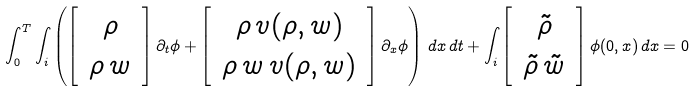<formula> <loc_0><loc_0><loc_500><loc_500>\int _ { 0 } ^ { T } \int _ { \real i } \left ( \left [ \, \begin{array} { c } \rho \\ \rho \, w \end{array} \, \right ] \partial _ { t } \phi + \left [ \, \begin{array} { c } \rho \, v ( \rho , w ) \\ \rho \, w \, v ( \rho , w ) \end{array} \, \right ] \partial _ { x } \phi \right ) \, d x \, d t + \int _ { \real i } \left [ \, \begin{array} { c } \tilde { \rho } \\ \tilde { \rho } \, \tilde { w } \end{array} \, \right ] \phi ( 0 , x ) \, d x = 0</formula> 